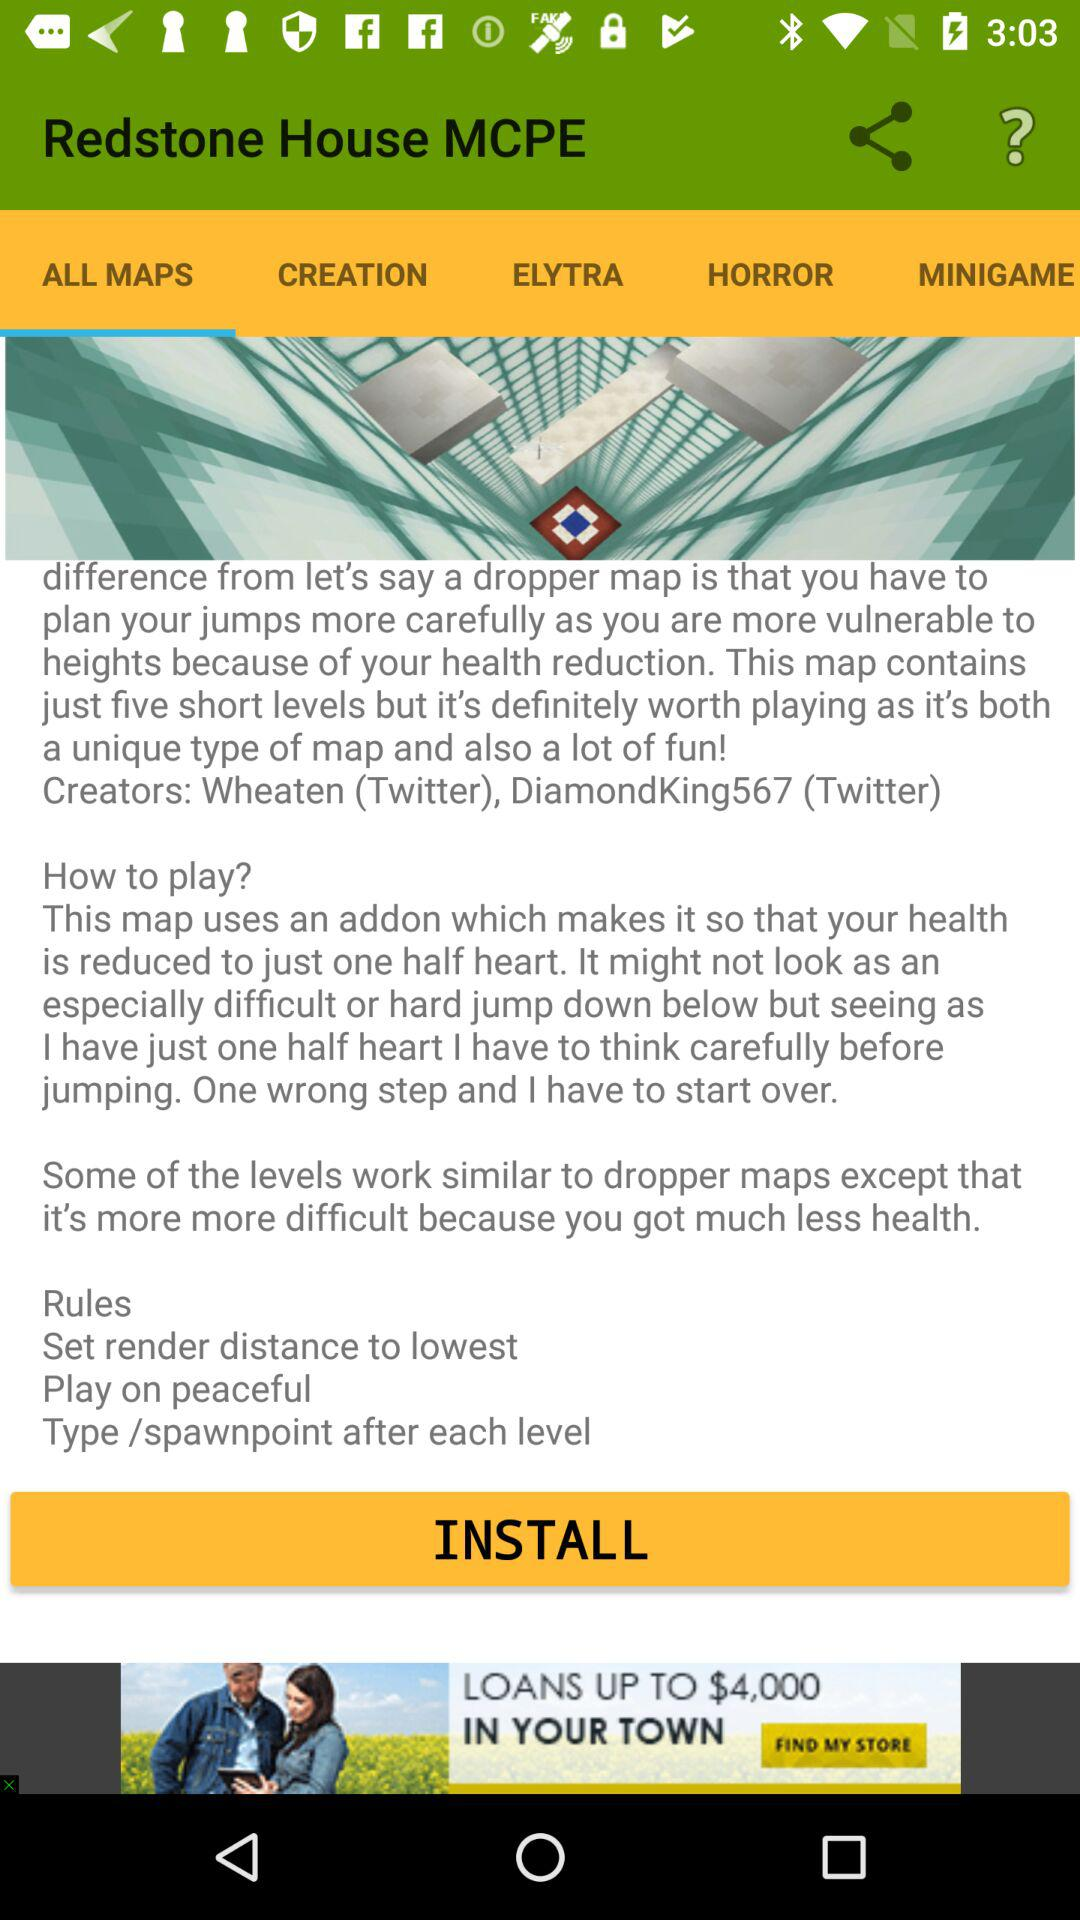Who is the creator of "Redstone House MCPE"? The creators of "Redstone House MCPE" are Wheaten and DiamondKing567. 